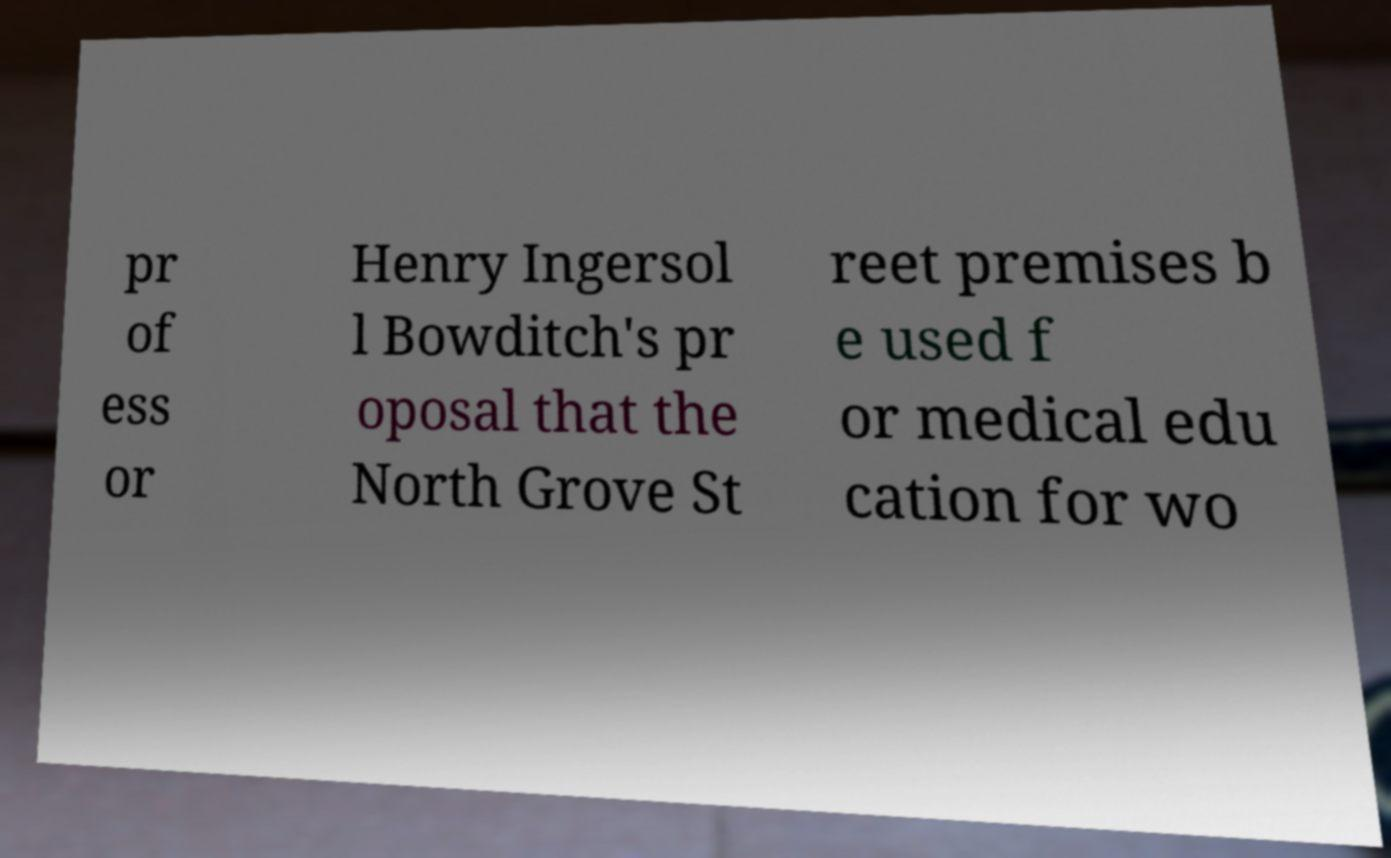Please identify and transcribe the text found in this image. pr of ess or Henry Ingersol l Bowditch's pr oposal that the North Grove St reet premises b e used f or medical edu cation for wo 